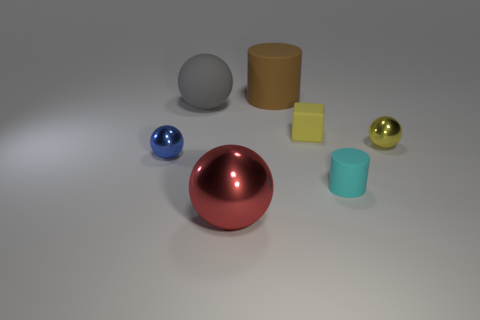Subtract all yellow spheres. How many spheres are left? 3 Subtract all yellow balls. How many balls are left? 3 Add 1 large cylinders. How many objects exist? 8 Subtract all cylinders. How many objects are left? 5 Subtract 2 balls. How many balls are left? 2 Subtract all brown cubes. How many gray balls are left? 1 Subtract all metal objects. Subtract all big rubber spheres. How many objects are left? 3 Add 4 small cyan rubber objects. How many small cyan rubber objects are left? 5 Add 5 gray spheres. How many gray spheres exist? 6 Subtract 1 cyan cylinders. How many objects are left? 6 